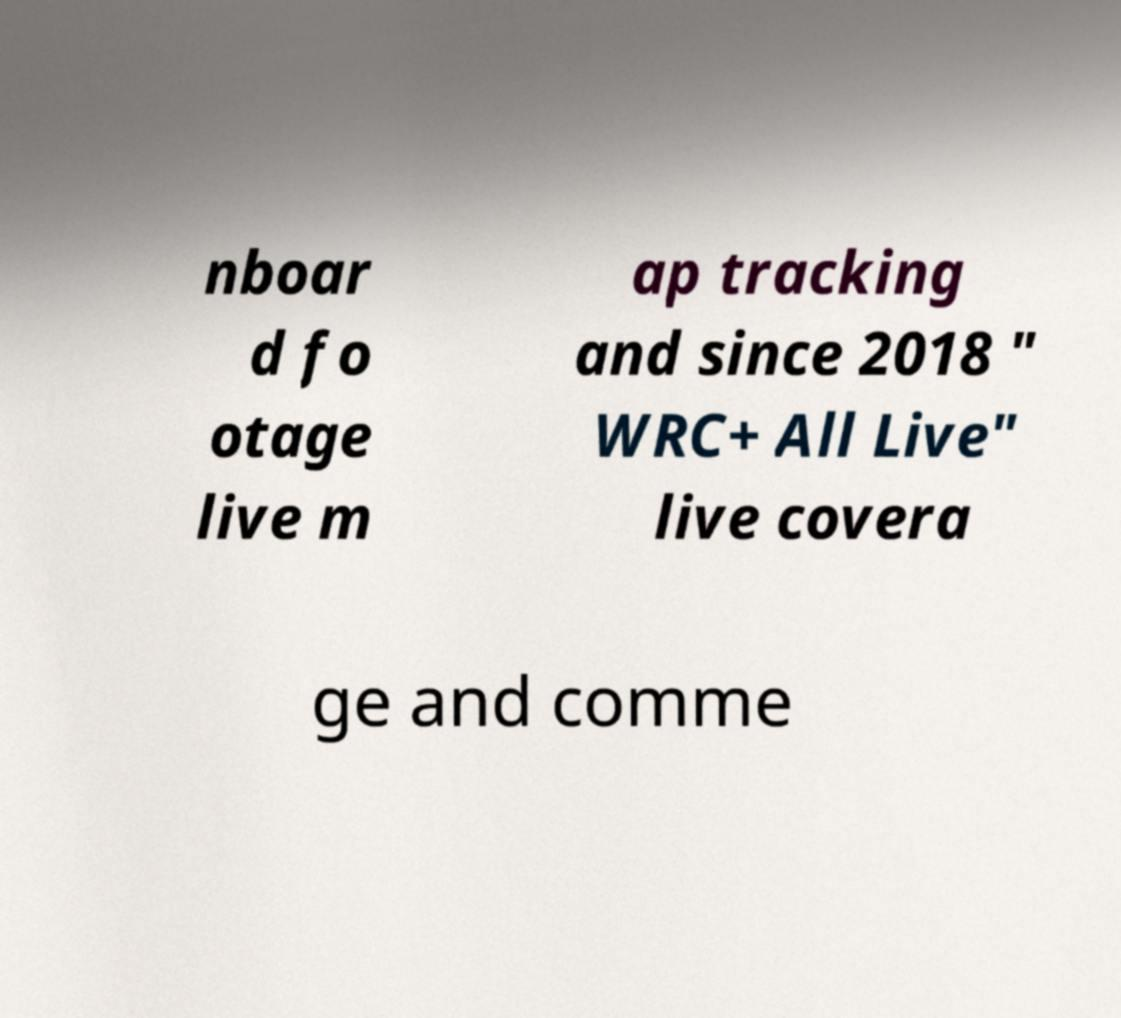For documentation purposes, I need the text within this image transcribed. Could you provide that? nboar d fo otage live m ap tracking and since 2018 " WRC+ All Live" live covera ge and comme 